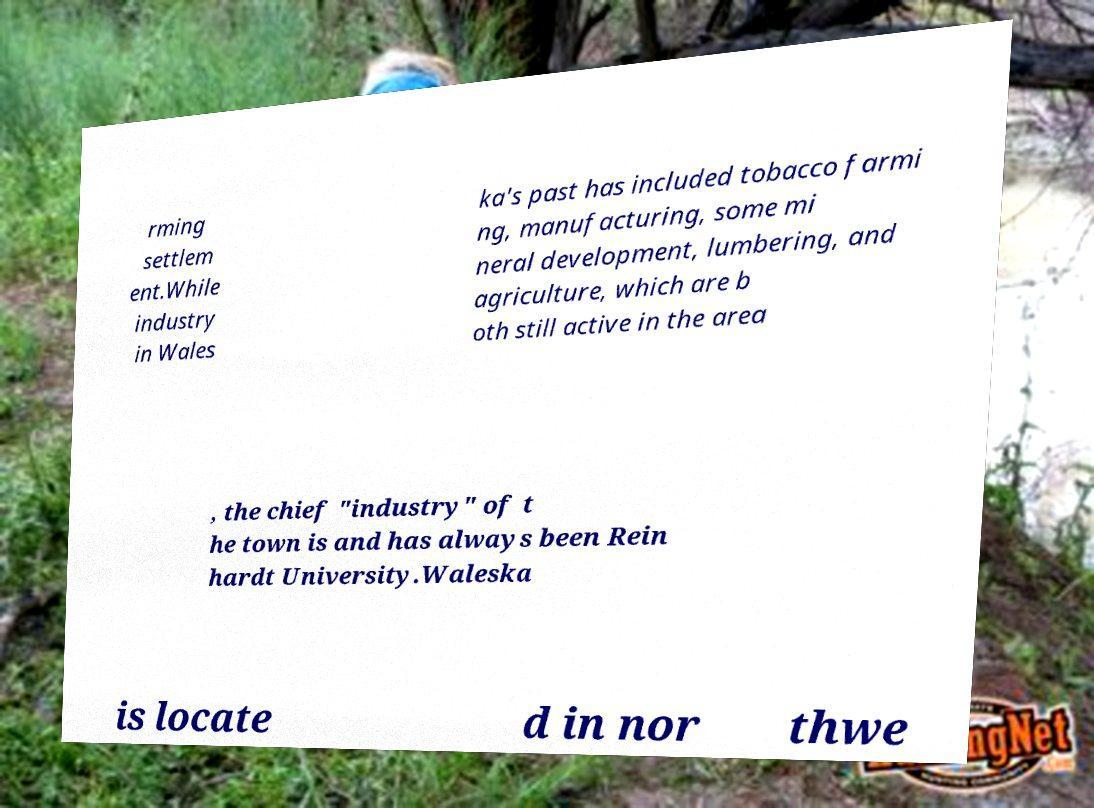Can you accurately transcribe the text from the provided image for me? rming settlem ent.While industry in Wales ka's past has included tobacco farmi ng, manufacturing, some mi neral development, lumbering, and agriculture, which are b oth still active in the area , the chief "industry" of t he town is and has always been Rein hardt University.Waleska is locate d in nor thwe 